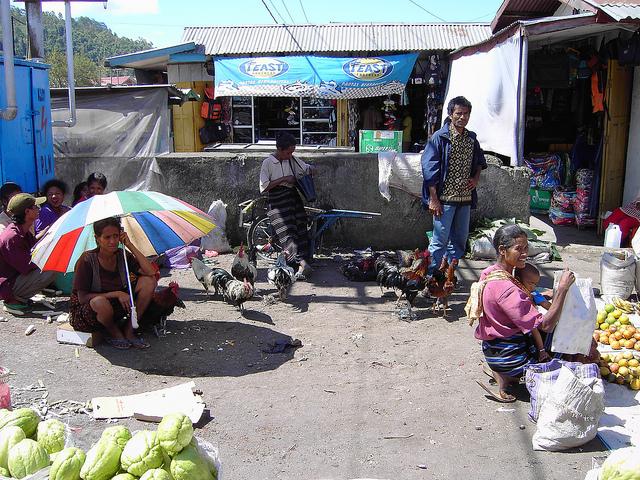How many people are there?
Keep it brief. 9. What is the woman holding over her head?
Answer briefly. Umbrella. Is produce being sold here?
Concise answer only. Yes. 